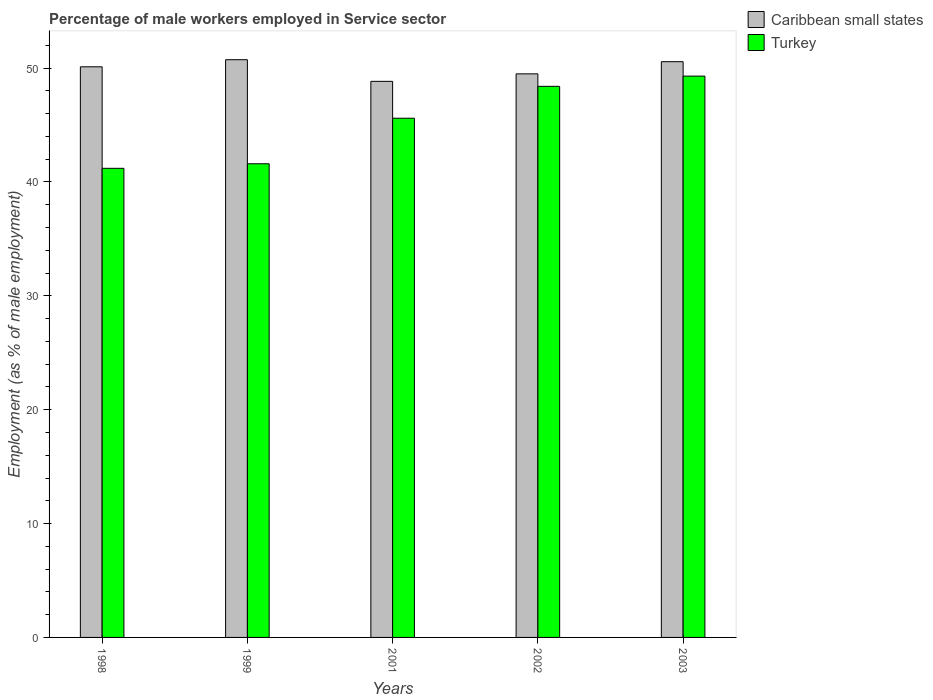Are the number of bars per tick equal to the number of legend labels?
Offer a terse response. Yes. How many bars are there on the 1st tick from the right?
Provide a short and direct response. 2. What is the label of the 3rd group of bars from the left?
Keep it short and to the point. 2001. In how many cases, is the number of bars for a given year not equal to the number of legend labels?
Keep it short and to the point. 0. What is the percentage of male workers employed in Service sector in Caribbean small states in 1999?
Provide a succinct answer. 50.74. Across all years, what is the maximum percentage of male workers employed in Service sector in Caribbean small states?
Make the answer very short. 50.74. Across all years, what is the minimum percentage of male workers employed in Service sector in Turkey?
Provide a short and direct response. 41.2. What is the total percentage of male workers employed in Service sector in Turkey in the graph?
Provide a succinct answer. 226.1. What is the difference between the percentage of male workers employed in Service sector in Turkey in 2001 and that in 2002?
Your answer should be compact. -2.8. What is the difference between the percentage of male workers employed in Service sector in Caribbean small states in 2003 and the percentage of male workers employed in Service sector in Turkey in 2002?
Ensure brevity in your answer.  2.17. What is the average percentage of male workers employed in Service sector in Turkey per year?
Keep it short and to the point. 45.22. In the year 2001, what is the difference between the percentage of male workers employed in Service sector in Caribbean small states and percentage of male workers employed in Service sector in Turkey?
Provide a short and direct response. 3.24. What is the ratio of the percentage of male workers employed in Service sector in Caribbean small states in 1998 to that in 1999?
Your answer should be very brief. 0.99. Is the difference between the percentage of male workers employed in Service sector in Caribbean small states in 1998 and 2003 greater than the difference between the percentage of male workers employed in Service sector in Turkey in 1998 and 2003?
Your answer should be compact. Yes. What is the difference between the highest and the second highest percentage of male workers employed in Service sector in Turkey?
Give a very brief answer. 0.9. What is the difference between the highest and the lowest percentage of male workers employed in Service sector in Turkey?
Your response must be concise. 8.1. In how many years, is the percentage of male workers employed in Service sector in Caribbean small states greater than the average percentage of male workers employed in Service sector in Caribbean small states taken over all years?
Make the answer very short. 3. Is the sum of the percentage of male workers employed in Service sector in Turkey in 1999 and 2001 greater than the maximum percentage of male workers employed in Service sector in Caribbean small states across all years?
Give a very brief answer. Yes. What does the 1st bar from the left in 1999 represents?
Your answer should be very brief. Caribbean small states. What does the 2nd bar from the right in 2001 represents?
Your response must be concise. Caribbean small states. How many bars are there?
Your answer should be very brief. 10. Are all the bars in the graph horizontal?
Offer a very short reply. No. Are the values on the major ticks of Y-axis written in scientific E-notation?
Your answer should be compact. No. Does the graph contain any zero values?
Offer a very short reply. No. Where does the legend appear in the graph?
Your response must be concise. Top right. How are the legend labels stacked?
Give a very brief answer. Vertical. What is the title of the graph?
Your response must be concise. Percentage of male workers employed in Service sector. Does "French Polynesia" appear as one of the legend labels in the graph?
Your answer should be compact. No. What is the label or title of the X-axis?
Ensure brevity in your answer.  Years. What is the label or title of the Y-axis?
Ensure brevity in your answer.  Employment (as % of male employment). What is the Employment (as % of male employment) in Caribbean small states in 1998?
Your answer should be compact. 50.12. What is the Employment (as % of male employment) of Turkey in 1998?
Give a very brief answer. 41.2. What is the Employment (as % of male employment) of Caribbean small states in 1999?
Offer a terse response. 50.74. What is the Employment (as % of male employment) of Turkey in 1999?
Your answer should be very brief. 41.6. What is the Employment (as % of male employment) in Caribbean small states in 2001?
Your answer should be very brief. 48.84. What is the Employment (as % of male employment) of Turkey in 2001?
Ensure brevity in your answer.  45.6. What is the Employment (as % of male employment) in Caribbean small states in 2002?
Your answer should be very brief. 49.5. What is the Employment (as % of male employment) in Turkey in 2002?
Provide a succinct answer. 48.4. What is the Employment (as % of male employment) of Caribbean small states in 2003?
Make the answer very short. 50.57. What is the Employment (as % of male employment) of Turkey in 2003?
Provide a short and direct response. 49.3. Across all years, what is the maximum Employment (as % of male employment) in Caribbean small states?
Give a very brief answer. 50.74. Across all years, what is the maximum Employment (as % of male employment) in Turkey?
Offer a very short reply. 49.3. Across all years, what is the minimum Employment (as % of male employment) of Caribbean small states?
Your answer should be very brief. 48.84. Across all years, what is the minimum Employment (as % of male employment) of Turkey?
Provide a short and direct response. 41.2. What is the total Employment (as % of male employment) of Caribbean small states in the graph?
Make the answer very short. 249.76. What is the total Employment (as % of male employment) in Turkey in the graph?
Ensure brevity in your answer.  226.1. What is the difference between the Employment (as % of male employment) of Caribbean small states in 1998 and that in 1999?
Make the answer very short. -0.62. What is the difference between the Employment (as % of male employment) in Caribbean small states in 1998 and that in 2001?
Provide a succinct answer. 1.28. What is the difference between the Employment (as % of male employment) in Turkey in 1998 and that in 2001?
Offer a very short reply. -4.4. What is the difference between the Employment (as % of male employment) of Caribbean small states in 1998 and that in 2002?
Your answer should be very brief. 0.62. What is the difference between the Employment (as % of male employment) of Caribbean small states in 1998 and that in 2003?
Give a very brief answer. -0.45. What is the difference between the Employment (as % of male employment) of Caribbean small states in 1999 and that in 2001?
Provide a short and direct response. 1.9. What is the difference between the Employment (as % of male employment) in Turkey in 1999 and that in 2001?
Your answer should be compact. -4. What is the difference between the Employment (as % of male employment) in Caribbean small states in 1999 and that in 2002?
Your response must be concise. 1.24. What is the difference between the Employment (as % of male employment) of Turkey in 1999 and that in 2002?
Keep it short and to the point. -6.8. What is the difference between the Employment (as % of male employment) of Caribbean small states in 1999 and that in 2003?
Give a very brief answer. 0.17. What is the difference between the Employment (as % of male employment) in Caribbean small states in 2001 and that in 2002?
Ensure brevity in your answer.  -0.66. What is the difference between the Employment (as % of male employment) of Turkey in 2001 and that in 2002?
Your response must be concise. -2.8. What is the difference between the Employment (as % of male employment) of Caribbean small states in 2001 and that in 2003?
Provide a succinct answer. -1.73. What is the difference between the Employment (as % of male employment) in Caribbean small states in 2002 and that in 2003?
Provide a succinct answer. -1.07. What is the difference between the Employment (as % of male employment) of Turkey in 2002 and that in 2003?
Give a very brief answer. -0.9. What is the difference between the Employment (as % of male employment) of Caribbean small states in 1998 and the Employment (as % of male employment) of Turkey in 1999?
Give a very brief answer. 8.52. What is the difference between the Employment (as % of male employment) in Caribbean small states in 1998 and the Employment (as % of male employment) in Turkey in 2001?
Keep it short and to the point. 4.52. What is the difference between the Employment (as % of male employment) in Caribbean small states in 1998 and the Employment (as % of male employment) in Turkey in 2002?
Make the answer very short. 1.72. What is the difference between the Employment (as % of male employment) of Caribbean small states in 1998 and the Employment (as % of male employment) of Turkey in 2003?
Offer a terse response. 0.82. What is the difference between the Employment (as % of male employment) in Caribbean small states in 1999 and the Employment (as % of male employment) in Turkey in 2001?
Provide a succinct answer. 5.14. What is the difference between the Employment (as % of male employment) of Caribbean small states in 1999 and the Employment (as % of male employment) of Turkey in 2002?
Offer a very short reply. 2.34. What is the difference between the Employment (as % of male employment) in Caribbean small states in 1999 and the Employment (as % of male employment) in Turkey in 2003?
Offer a very short reply. 1.44. What is the difference between the Employment (as % of male employment) of Caribbean small states in 2001 and the Employment (as % of male employment) of Turkey in 2002?
Keep it short and to the point. 0.44. What is the difference between the Employment (as % of male employment) in Caribbean small states in 2001 and the Employment (as % of male employment) in Turkey in 2003?
Keep it short and to the point. -0.46. What is the difference between the Employment (as % of male employment) in Caribbean small states in 2002 and the Employment (as % of male employment) in Turkey in 2003?
Provide a short and direct response. 0.2. What is the average Employment (as % of male employment) in Caribbean small states per year?
Provide a succinct answer. 49.95. What is the average Employment (as % of male employment) of Turkey per year?
Your response must be concise. 45.22. In the year 1998, what is the difference between the Employment (as % of male employment) of Caribbean small states and Employment (as % of male employment) of Turkey?
Offer a very short reply. 8.92. In the year 1999, what is the difference between the Employment (as % of male employment) of Caribbean small states and Employment (as % of male employment) of Turkey?
Offer a very short reply. 9.14. In the year 2001, what is the difference between the Employment (as % of male employment) of Caribbean small states and Employment (as % of male employment) of Turkey?
Ensure brevity in your answer.  3.24. In the year 2002, what is the difference between the Employment (as % of male employment) of Caribbean small states and Employment (as % of male employment) of Turkey?
Keep it short and to the point. 1.1. In the year 2003, what is the difference between the Employment (as % of male employment) of Caribbean small states and Employment (as % of male employment) of Turkey?
Provide a succinct answer. 1.27. What is the ratio of the Employment (as % of male employment) in Turkey in 1998 to that in 1999?
Make the answer very short. 0.99. What is the ratio of the Employment (as % of male employment) of Caribbean small states in 1998 to that in 2001?
Your answer should be very brief. 1.03. What is the ratio of the Employment (as % of male employment) in Turkey in 1998 to that in 2001?
Provide a short and direct response. 0.9. What is the ratio of the Employment (as % of male employment) of Caribbean small states in 1998 to that in 2002?
Offer a terse response. 1.01. What is the ratio of the Employment (as % of male employment) in Turkey in 1998 to that in 2002?
Offer a terse response. 0.85. What is the ratio of the Employment (as % of male employment) of Caribbean small states in 1998 to that in 2003?
Provide a short and direct response. 0.99. What is the ratio of the Employment (as % of male employment) of Turkey in 1998 to that in 2003?
Give a very brief answer. 0.84. What is the ratio of the Employment (as % of male employment) in Caribbean small states in 1999 to that in 2001?
Offer a very short reply. 1.04. What is the ratio of the Employment (as % of male employment) in Turkey in 1999 to that in 2001?
Give a very brief answer. 0.91. What is the ratio of the Employment (as % of male employment) of Caribbean small states in 1999 to that in 2002?
Keep it short and to the point. 1.03. What is the ratio of the Employment (as % of male employment) in Turkey in 1999 to that in 2002?
Offer a terse response. 0.86. What is the ratio of the Employment (as % of male employment) of Caribbean small states in 1999 to that in 2003?
Provide a succinct answer. 1. What is the ratio of the Employment (as % of male employment) in Turkey in 1999 to that in 2003?
Keep it short and to the point. 0.84. What is the ratio of the Employment (as % of male employment) in Caribbean small states in 2001 to that in 2002?
Provide a short and direct response. 0.99. What is the ratio of the Employment (as % of male employment) in Turkey in 2001 to that in 2002?
Your answer should be very brief. 0.94. What is the ratio of the Employment (as % of male employment) of Caribbean small states in 2001 to that in 2003?
Give a very brief answer. 0.97. What is the ratio of the Employment (as % of male employment) in Turkey in 2001 to that in 2003?
Your response must be concise. 0.92. What is the ratio of the Employment (as % of male employment) in Caribbean small states in 2002 to that in 2003?
Your answer should be very brief. 0.98. What is the ratio of the Employment (as % of male employment) of Turkey in 2002 to that in 2003?
Offer a terse response. 0.98. What is the difference between the highest and the second highest Employment (as % of male employment) in Caribbean small states?
Offer a terse response. 0.17. What is the difference between the highest and the second highest Employment (as % of male employment) of Turkey?
Your response must be concise. 0.9. What is the difference between the highest and the lowest Employment (as % of male employment) of Caribbean small states?
Make the answer very short. 1.9. 